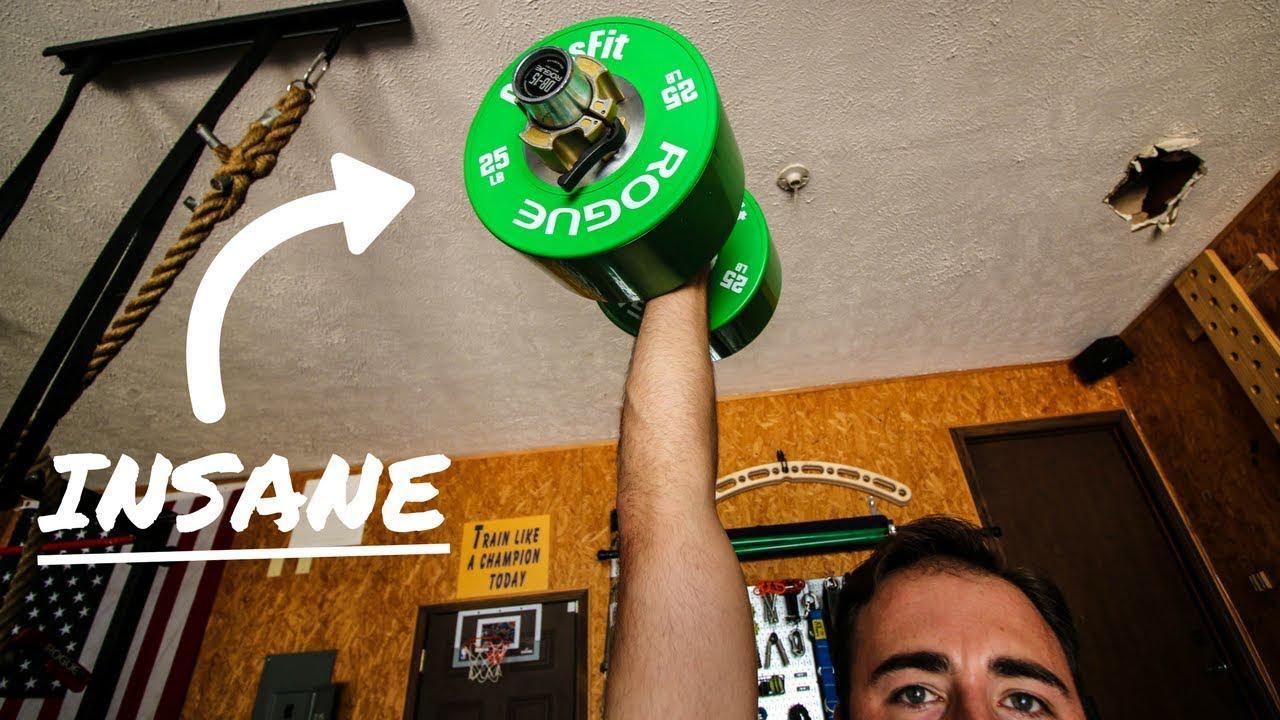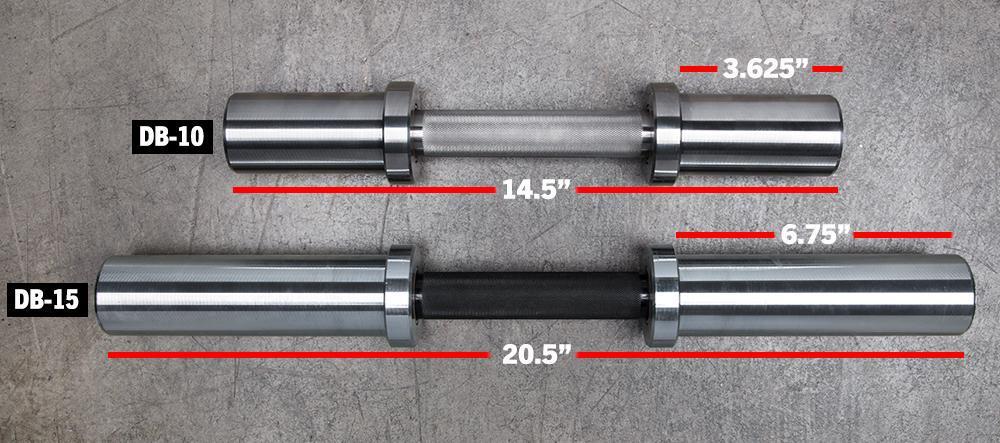The first image is the image on the left, the second image is the image on the right. For the images shown, is this caption "A weightlifter in one image has one arm stretched straight up, holding a weighted barbell." true? Answer yes or no. Yes. The first image is the image on the left, the second image is the image on the right. Analyze the images presented: Is the assertion "An image shows a forward-facing man lifting a green barbell with the hand on the left of the image." valid? Answer yes or no. Yes. 